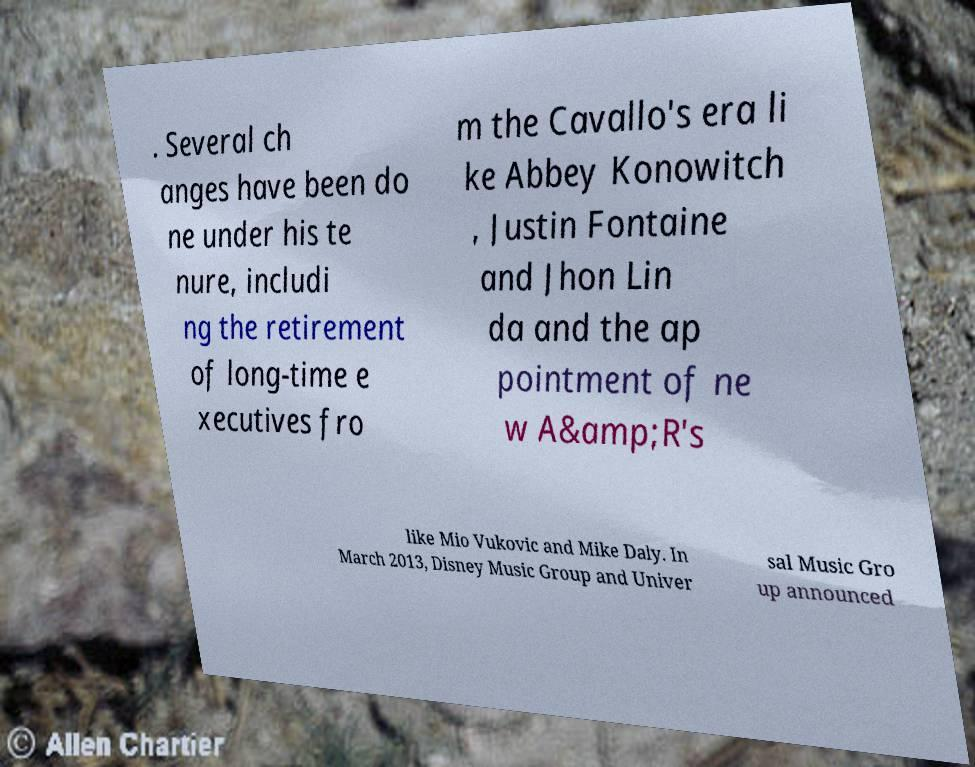What messages or text are displayed in this image? I need them in a readable, typed format. . Several ch anges have been do ne under his te nure, includi ng the retirement of long-time e xecutives fro m the Cavallo's era li ke Abbey Konowitch , Justin Fontaine and Jhon Lin da and the ap pointment of ne w A&amp;R's like Mio Vukovic and Mike Daly. In March 2013, Disney Music Group and Univer sal Music Gro up announced 